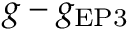Convert formula to latex. <formula><loc_0><loc_0><loc_500><loc_500>g - g _ { E P 3 }</formula> 